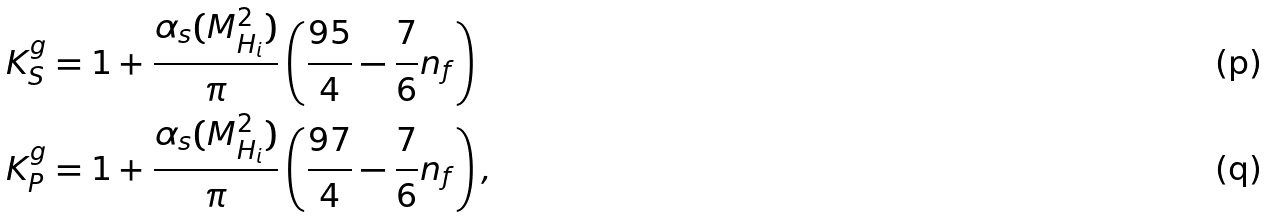Convert formula to latex. <formula><loc_0><loc_0><loc_500><loc_500>K ^ { g } _ { S } & = 1 + \frac { \alpha _ { s } ( M _ { H _ { i } } ^ { 2 } ) } { \pi } \left ( \frac { 9 5 } { 4 } - \frac { 7 } { 6 } n _ { f } \right ) \\ K ^ { g } _ { P } & = 1 + \frac { \alpha _ { s } ( M _ { H _ { i } } ^ { 2 } ) } { \pi } \left ( \frac { 9 7 } { 4 } - \frac { 7 } { 6 } n _ { f } \right ) ,</formula> 